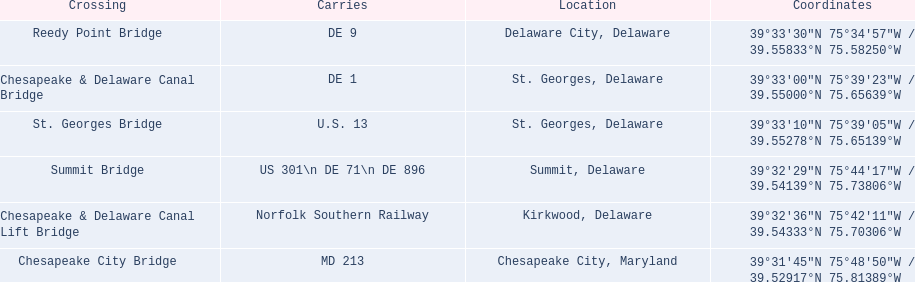What is being carried in the canal? MD 213, US 301\n DE 71\n DE 896, Norfolk Southern Railway, DE 1, U.S. 13, DE 9. Of those which has the largest number of different routes? US 301\n DE 71\n DE 896. To which crossing does that relate? Summit Bridge. 